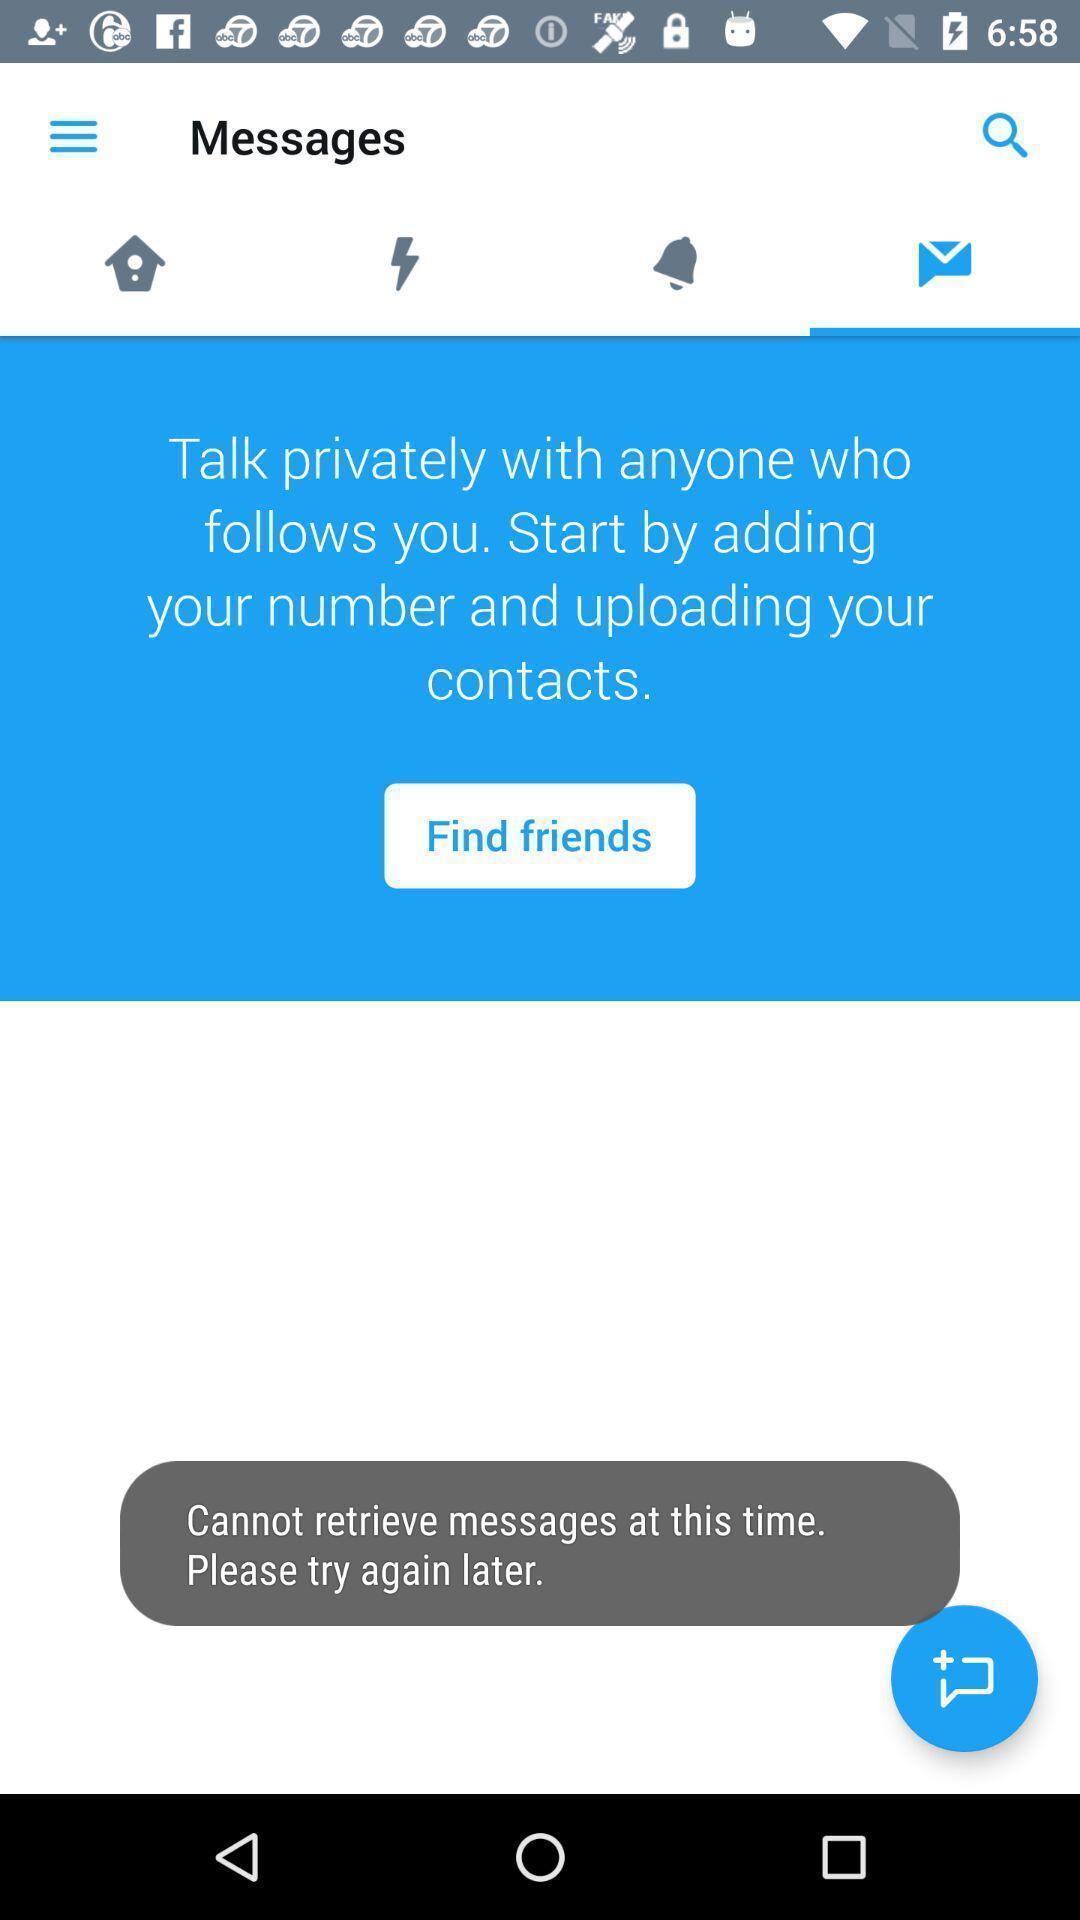Give me a narrative description of this picture. Screen showing messages. 